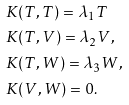Convert formula to latex. <formula><loc_0><loc_0><loc_500><loc_500>& K ( T , T ) = \lambda _ { 1 } T \\ & K ( T , V ) = \lambda _ { 2 } V , \\ & K ( T , W ) = \lambda _ { 3 } W , \\ & K ( V , W ) = 0 .</formula> 